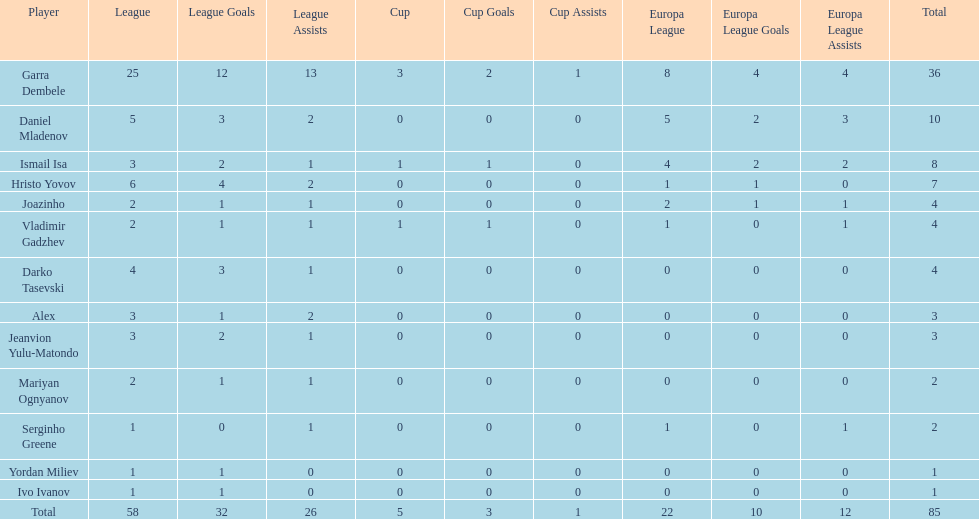What is the sum of the cup total and the europa league total? 27. 